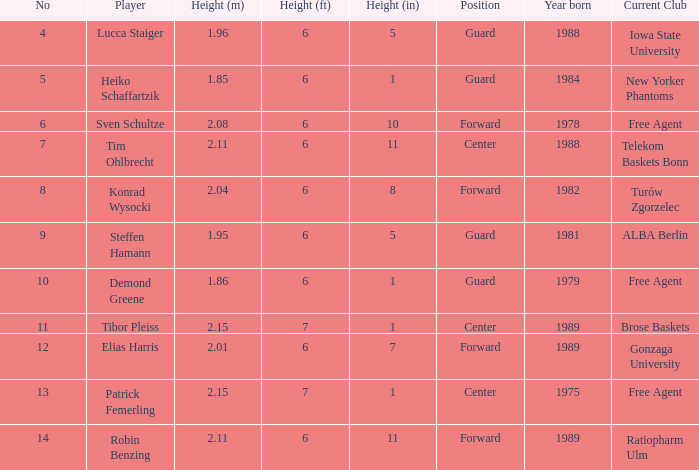Name the height of demond greene 6' 01". 